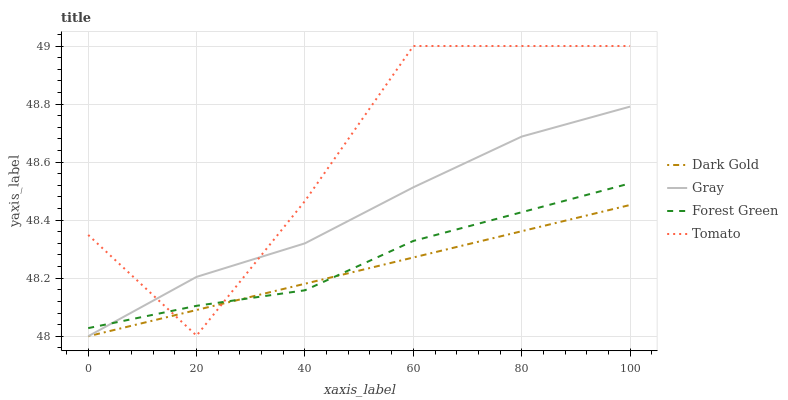Does Dark Gold have the minimum area under the curve?
Answer yes or no. Yes. Does Tomato have the maximum area under the curve?
Answer yes or no. Yes. Does Gray have the minimum area under the curve?
Answer yes or no. No. Does Gray have the maximum area under the curve?
Answer yes or no. No. Is Dark Gold the smoothest?
Answer yes or no. Yes. Is Tomato the roughest?
Answer yes or no. Yes. Is Gray the smoothest?
Answer yes or no. No. Is Gray the roughest?
Answer yes or no. No. Does Gray have the lowest value?
Answer yes or no. Yes. Does Forest Green have the lowest value?
Answer yes or no. No. Does Tomato have the highest value?
Answer yes or no. Yes. Does Gray have the highest value?
Answer yes or no. No. Does Gray intersect Forest Green?
Answer yes or no. Yes. Is Gray less than Forest Green?
Answer yes or no. No. Is Gray greater than Forest Green?
Answer yes or no. No. 